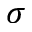<formula> <loc_0><loc_0><loc_500><loc_500>\sigma</formula> 